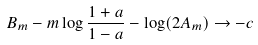<formula> <loc_0><loc_0><loc_500><loc_500>B _ { m } - m \log \frac { 1 + a } { 1 - a } - \log ( 2 A _ { m } ) \to - c</formula> 